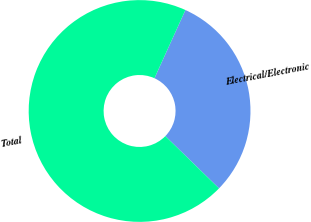<chart> <loc_0><loc_0><loc_500><loc_500><pie_chart><fcel>Electrical/Electronic<fcel>Total<nl><fcel>30.51%<fcel>69.49%<nl></chart> 